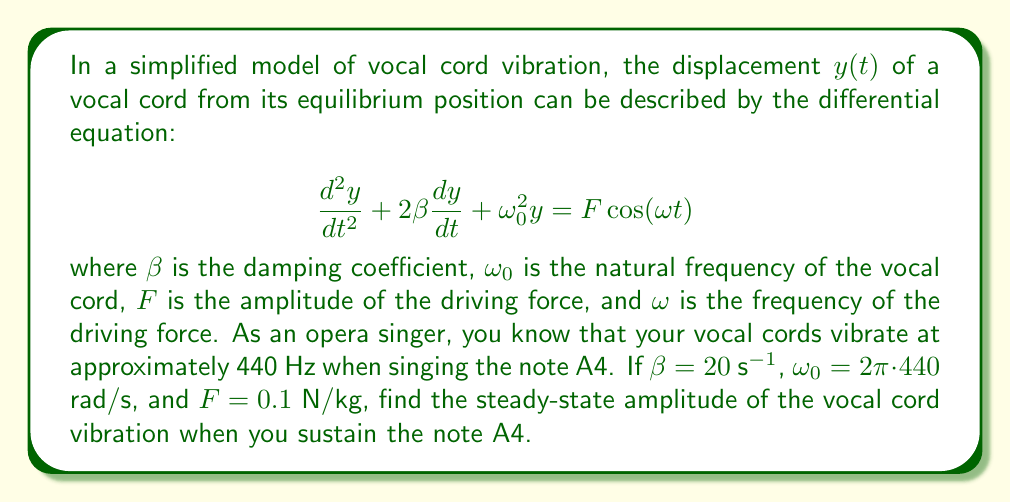Provide a solution to this math problem. Let's approach this step-by-step:

1) For a driven harmonic oscillator, the steady-state solution has the form:

   $$y(t) = A\cos(\omega t - \phi)$$

   where $A$ is the amplitude we're looking for.

2) The amplitude $A$ is given by the formula:

   $$A = \frac{F}{\sqrt{(\omega_0^2 - \omega^2)^2 + 4\beta^2\omega^2}}$$

3) We're given:
   - $\beta = 20$ s^(-1)
   - $\omega_0 = 2\pi \cdot 440$ rad/s
   - $F = 0.1$ N/kg
   - $\omega = 2\pi \cdot 440$ rad/s (since we're singing A4)

4) Let's substitute these values into our amplitude formula:

   $$A = \frac{0.1}{\sqrt{((2\pi \cdot 440)^2 - (2\pi \cdot 440)^2)^2 + 4(20)^2(2\pi \cdot 440)^2}}$$

5) Simplify:
   - $(2\pi \cdot 440)^2 - (2\pi \cdot 440)^2 = 0$
   - $4(20)^2(2\pi \cdot 440)^2 = 4 \cdot 400 \cdot 4\pi^2 \cdot 440^2$

6) Our equation becomes:

   $$A = \frac{0.1}{\sqrt{0^2 + 4 \cdot 400 \cdot 4\pi^2 \cdot 440^2}}$$

7) Simplify further:

   $$A = \frac{0.1}{\sqrt{2,764,800\pi^2}}$$

8) Calculate the final result:

   $$A \approx 1.2 \times 10^{-6} \text{ m}$$
Answer: $1.2 \times 10^{-6}$ m 